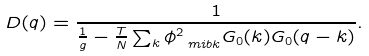<formula> <loc_0><loc_0><loc_500><loc_500>D ( q ) = \frac { 1 } { { \frac { 1 } { g } } - { \frac { T } { N } } \sum _ { k } \phi _ { \ m i b k } ^ { 2 } G _ { 0 } ( k ) G _ { 0 } ( q - k ) } .</formula> 